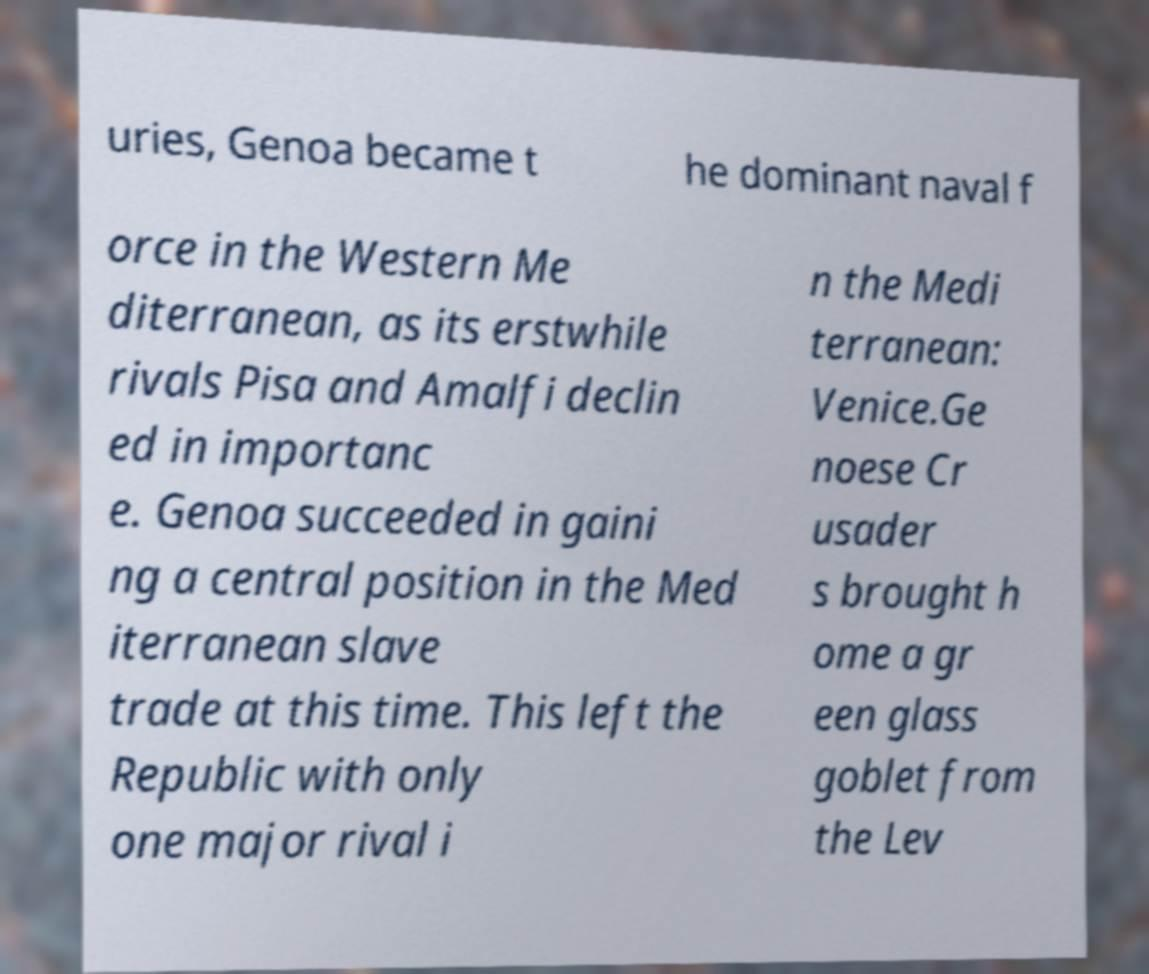I need the written content from this picture converted into text. Can you do that? uries, Genoa became t he dominant naval f orce in the Western Me diterranean, as its erstwhile rivals Pisa and Amalfi declin ed in importanc e. Genoa succeeded in gaini ng a central position in the Med iterranean slave trade at this time. This left the Republic with only one major rival i n the Medi terranean: Venice.Ge noese Cr usader s brought h ome a gr een glass goblet from the Lev 